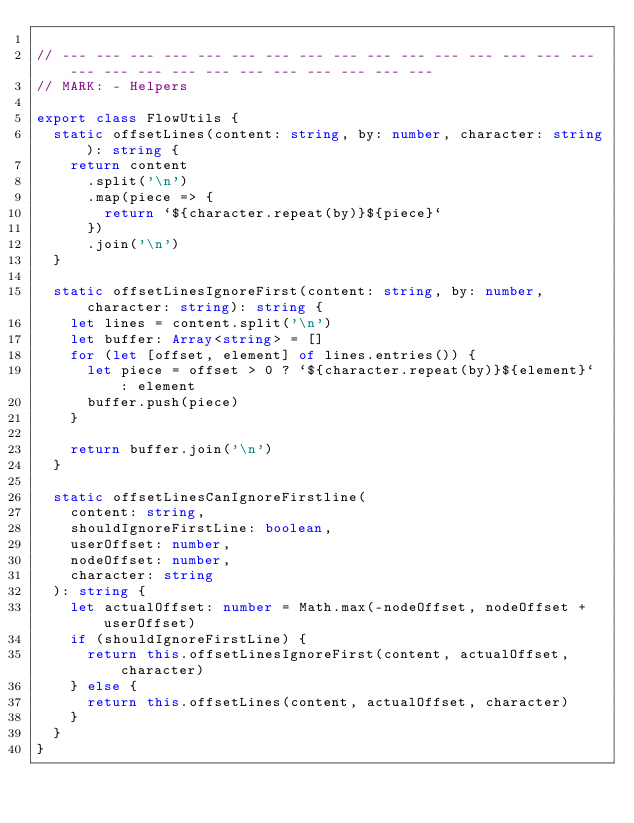Convert code to text. <code><loc_0><loc_0><loc_500><loc_500><_TypeScript_>
// --- --- --- --- --- --- --- --- --- --- --- --- --- --- --- --- --- --- --- --- --- --- --- --- --- --- ---
// MARK: - Helpers

export class FlowUtils {
  static offsetLines(content: string, by: number, character: string): string {
    return content
      .split('\n')
      .map(piece => {
        return `${character.repeat(by)}${piece}`
      })
      .join('\n')
  }

  static offsetLinesIgnoreFirst(content: string, by: number, character: string): string {
    let lines = content.split('\n')
    let buffer: Array<string> = []
    for (let [offset, element] of lines.entries()) {
      let piece = offset > 0 ? `${character.repeat(by)}${element}` : element
      buffer.push(piece)
    }

    return buffer.join('\n')
  }

  static offsetLinesCanIgnoreFirstline(
    content: string,
    shouldIgnoreFirstLine: boolean,
    userOffset: number,
    nodeOffset: number,
    character: string
  ): string {
    let actualOffset: number = Math.max(-nodeOffset, nodeOffset + userOffset)
    if (shouldIgnoreFirstLine) {
      return this.offsetLinesIgnoreFirst(content, actualOffset, character)
    } else {
      return this.offsetLines(content, actualOffset, character)
    }
  }
}
</code> 